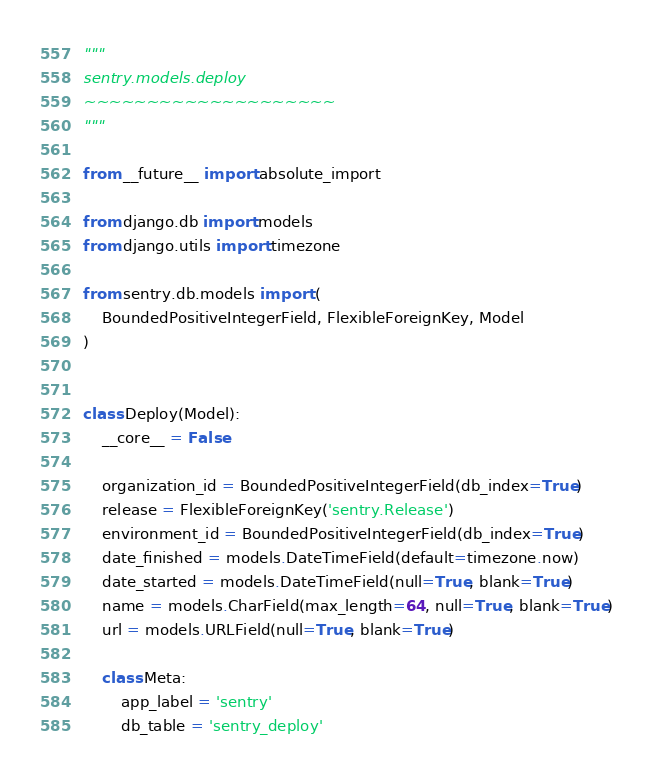Convert code to text. <code><loc_0><loc_0><loc_500><loc_500><_Python_>"""
sentry.models.deploy
~~~~~~~~~~~~~~~~~~~~
"""

from __future__ import absolute_import

from django.db import models
from django.utils import timezone

from sentry.db.models import (
    BoundedPositiveIntegerField, FlexibleForeignKey, Model
)


class Deploy(Model):
    __core__ = False

    organization_id = BoundedPositiveIntegerField(db_index=True)
    release = FlexibleForeignKey('sentry.Release')
    environment_id = BoundedPositiveIntegerField(db_index=True)
    date_finished = models.DateTimeField(default=timezone.now)
    date_started = models.DateTimeField(null=True, blank=True)
    name = models.CharField(max_length=64, null=True, blank=True)
    url = models.URLField(null=True, blank=True)

    class Meta:
        app_label = 'sentry'
        db_table = 'sentry_deploy'
</code> 